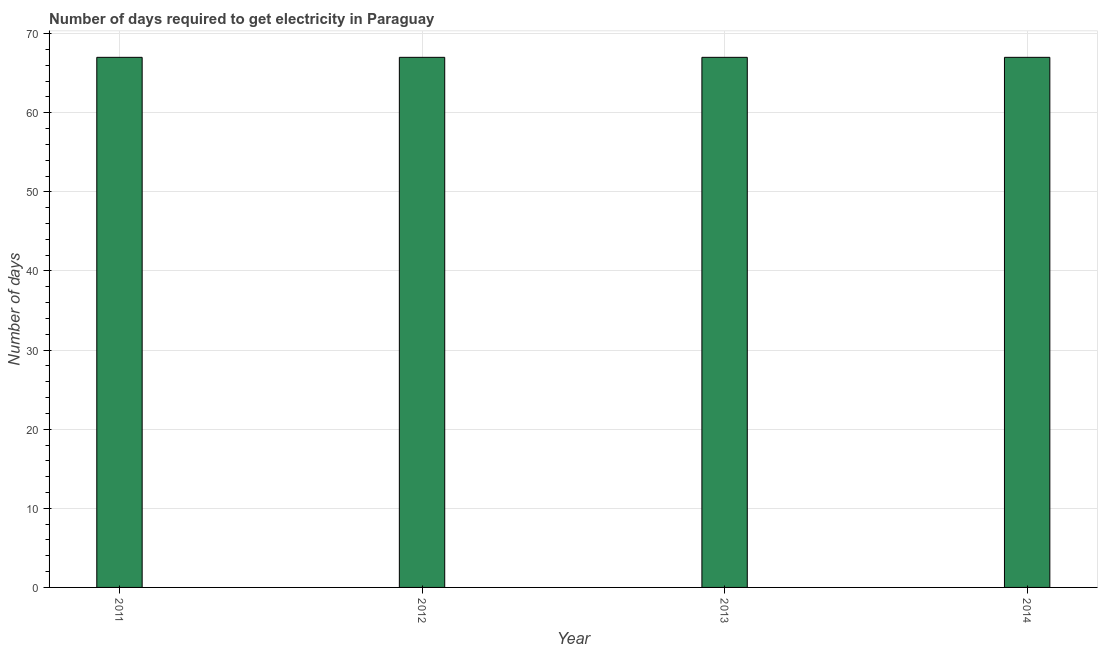Does the graph contain grids?
Ensure brevity in your answer.  Yes. What is the title of the graph?
Ensure brevity in your answer.  Number of days required to get electricity in Paraguay. What is the label or title of the Y-axis?
Offer a terse response. Number of days. What is the time to get electricity in 2011?
Offer a very short reply. 67. Across all years, what is the maximum time to get electricity?
Make the answer very short. 67. In which year was the time to get electricity minimum?
Your answer should be very brief. 2011. What is the sum of the time to get electricity?
Your answer should be very brief. 268. What is the average time to get electricity per year?
Make the answer very short. 67. What is the median time to get electricity?
Your response must be concise. 67. Do a majority of the years between 2014 and 2011 (inclusive) have time to get electricity greater than 14 ?
Your response must be concise. Yes. What is the ratio of the time to get electricity in 2012 to that in 2013?
Offer a terse response. 1. Is the time to get electricity in 2011 less than that in 2014?
Your answer should be compact. No. Is the difference between the time to get electricity in 2012 and 2013 greater than the difference between any two years?
Your response must be concise. Yes. What is the difference between the highest and the second highest time to get electricity?
Make the answer very short. 0. In how many years, is the time to get electricity greater than the average time to get electricity taken over all years?
Keep it short and to the point. 0. What is the difference between two consecutive major ticks on the Y-axis?
Provide a succinct answer. 10. What is the Number of days in 2011?
Offer a terse response. 67. What is the Number of days in 2013?
Offer a very short reply. 67. What is the difference between the Number of days in 2011 and 2014?
Offer a very short reply. 0. What is the difference between the Number of days in 2012 and 2013?
Provide a short and direct response. 0. What is the difference between the Number of days in 2012 and 2014?
Your answer should be compact. 0. What is the ratio of the Number of days in 2011 to that in 2014?
Provide a succinct answer. 1. What is the ratio of the Number of days in 2013 to that in 2014?
Offer a terse response. 1. 